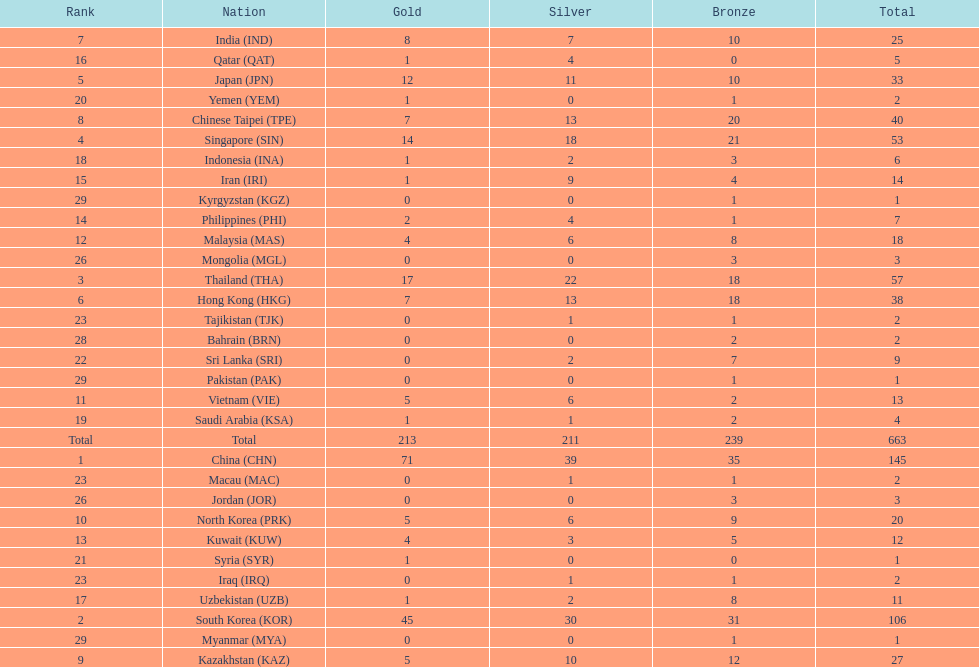What were the number of medals iran earned? 14. 